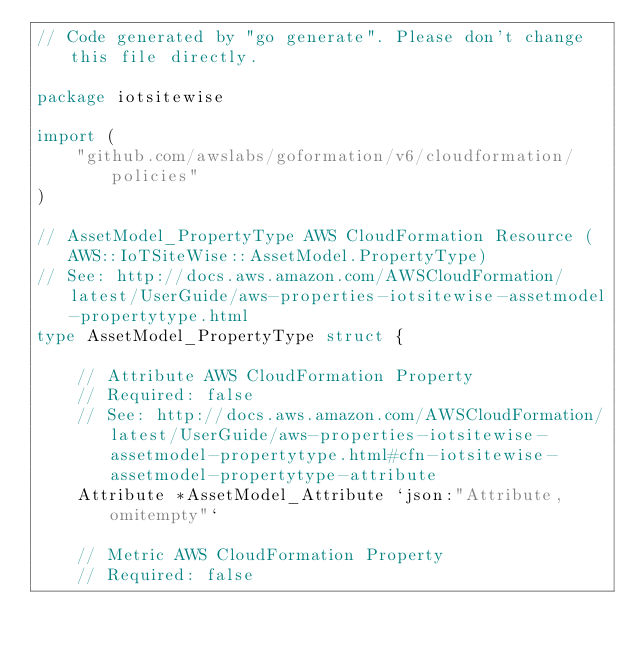Convert code to text. <code><loc_0><loc_0><loc_500><loc_500><_Go_>// Code generated by "go generate". Please don't change this file directly.

package iotsitewise

import (
	"github.com/awslabs/goformation/v6/cloudformation/policies"
)

// AssetModel_PropertyType AWS CloudFormation Resource (AWS::IoTSiteWise::AssetModel.PropertyType)
// See: http://docs.aws.amazon.com/AWSCloudFormation/latest/UserGuide/aws-properties-iotsitewise-assetmodel-propertytype.html
type AssetModel_PropertyType struct {

	// Attribute AWS CloudFormation Property
	// Required: false
	// See: http://docs.aws.amazon.com/AWSCloudFormation/latest/UserGuide/aws-properties-iotsitewise-assetmodel-propertytype.html#cfn-iotsitewise-assetmodel-propertytype-attribute
	Attribute *AssetModel_Attribute `json:"Attribute,omitempty"`

	// Metric AWS CloudFormation Property
	// Required: false</code> 